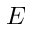Convert formula to latex. <formula><loc_0><loc_0><loc_500><loc_500>E</formula> 